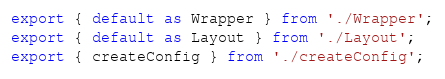Convert code to text. <code><loc_0><loc_0><loc_500><loc_500><_JavaScript_>export { default as Wrapper } from './Wrapper';
export { default as Layout } from './Layout';
export { createConfig } from './createConfig';
</code> 